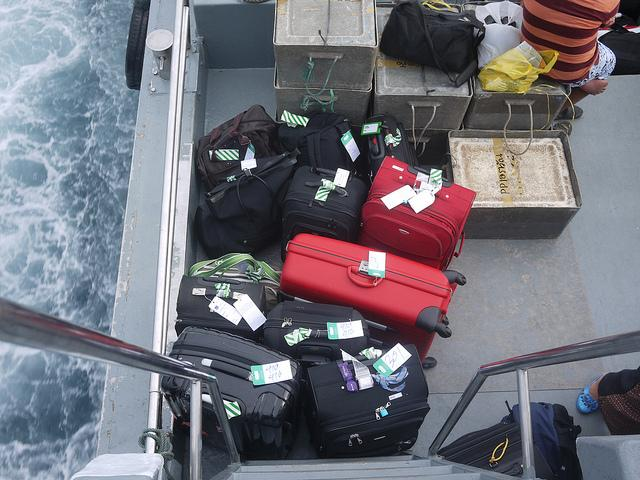How are bags identified here?

Choices:
A) tracking device
B) color
C) tags
D) they aren't tags 